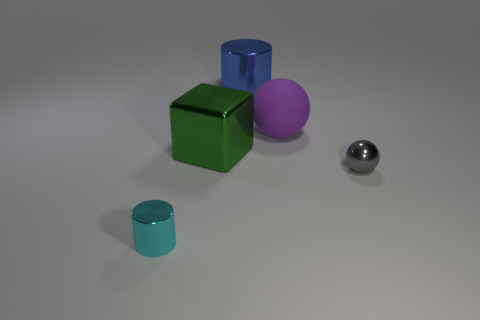Add 4 big things. How many objects exist? 9 Subtract all cylinders. How many objects are left? 3 Add 4 tiny things. How many tiny things are left? 6 Add 5 large rubber cylinders. How many large rubber cylinders exist? 5 Subtract 0 yellow cylinders. How many objects are left? 5 Subtract all tiny red things. Subtract all large blue objects. How many objects are left? 4 